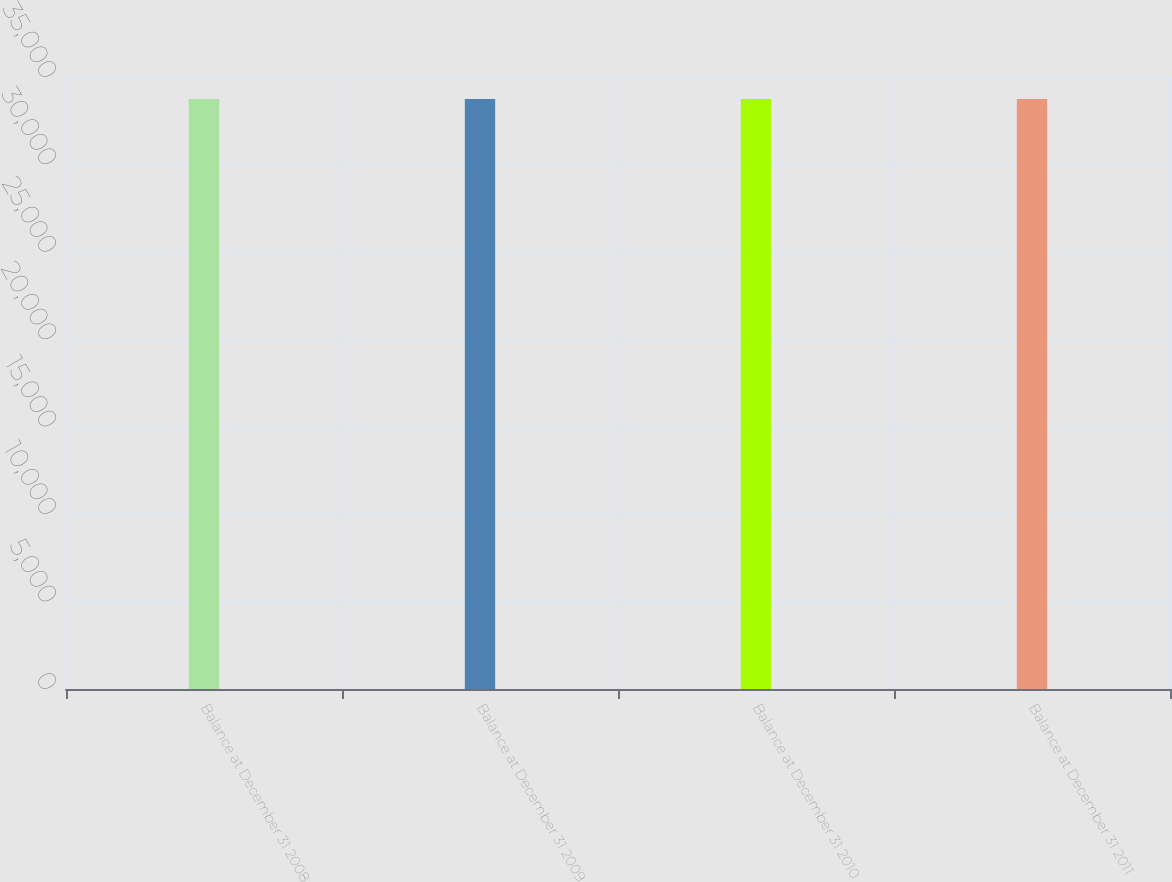Convert chart to OTSL. <chart><loc_0><loc_0><loc_500><loc_500><bar_chart><fcel>Balance at December 31 2008<fcel>Balance at December 31 2009<fcel>Balance at December 31 2010<fcel>Balance at December 31 2011<nl><fcel>33744<fcel>33744.1<fcel>33744.2<fcel>33744.3<nl></chart> 